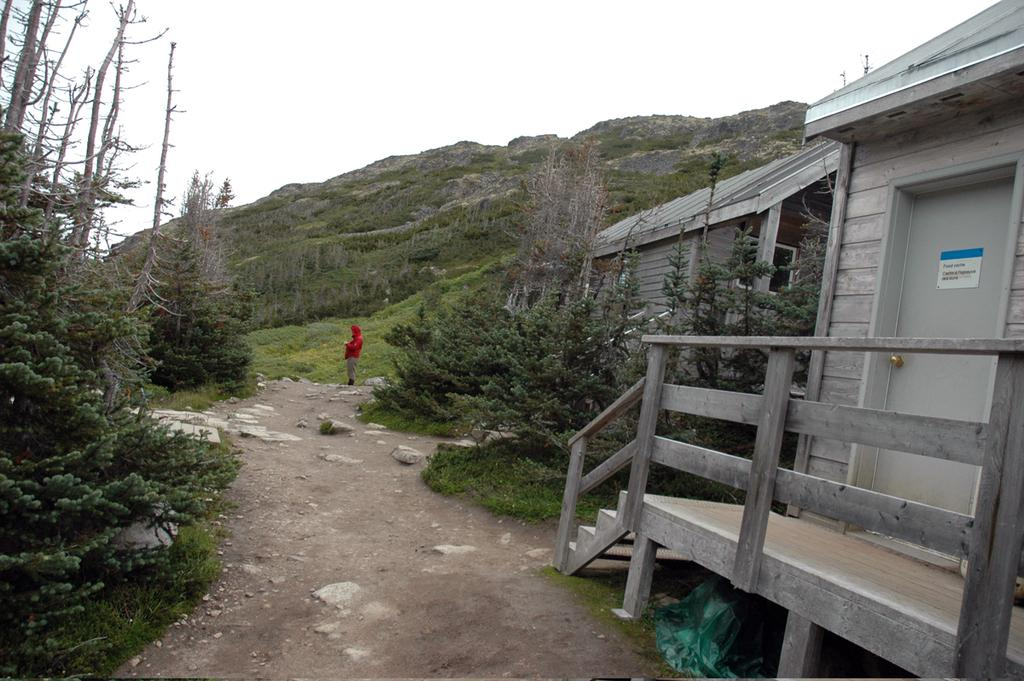What type of houses are in the image? There are wooden houses in the image. What other natural elements can be seen in the image? There are trees in the image. What is the person in the image doing? The person is standing on the road in the image. What can be seen in the distance in the image? There are mountains visible in the background of the image. What is visible above the houses and trees in the image? The sky is visible in the background of the image. Where might this image have been taken? The image appears to have been taken near the mountains. Where is the scarecrow located in the image? There is no scarecrow present in the image. What type of vacation is the person in the image taking? There is no indication of a vacation in the image; it simply shows a person standing on the road near wooden houses, trees, mountains, and the sky. 